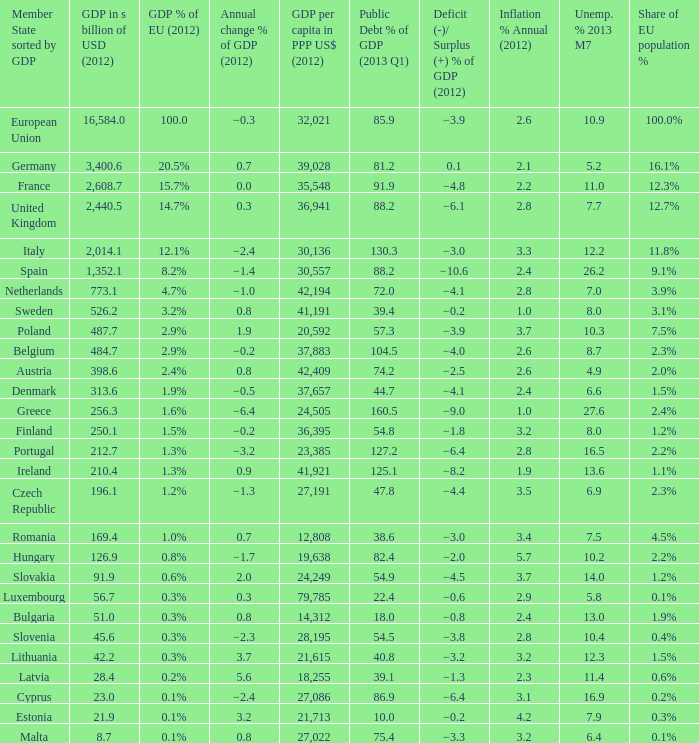What is the GDP % of EU in 2012 of the country with a GDP in billions of USD in 2012 of 256.3? 1.6%. 